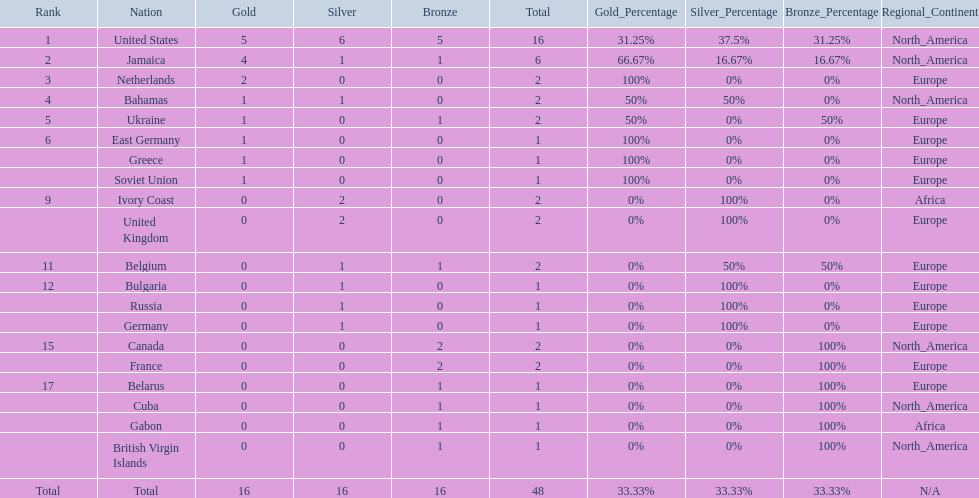Which countries participated? United States, Jamaica, Netherlands, Bahamas, Ukraine, East Germany, Greece, Soviet Union, Ivory Coast, United Kingdom, Belgium, Bulgaria, Russia, Germany, Canada, France, Belarus, Cuba, Gabon, British Virgin Islands. How many gold medals were won by each? 5, 4, 2, 1, 1, 1, 1, 1, 0, 0, 0, 0, 0, 0, 0, 0, 0, 0, 0, 0. And which country won the most? United States. 